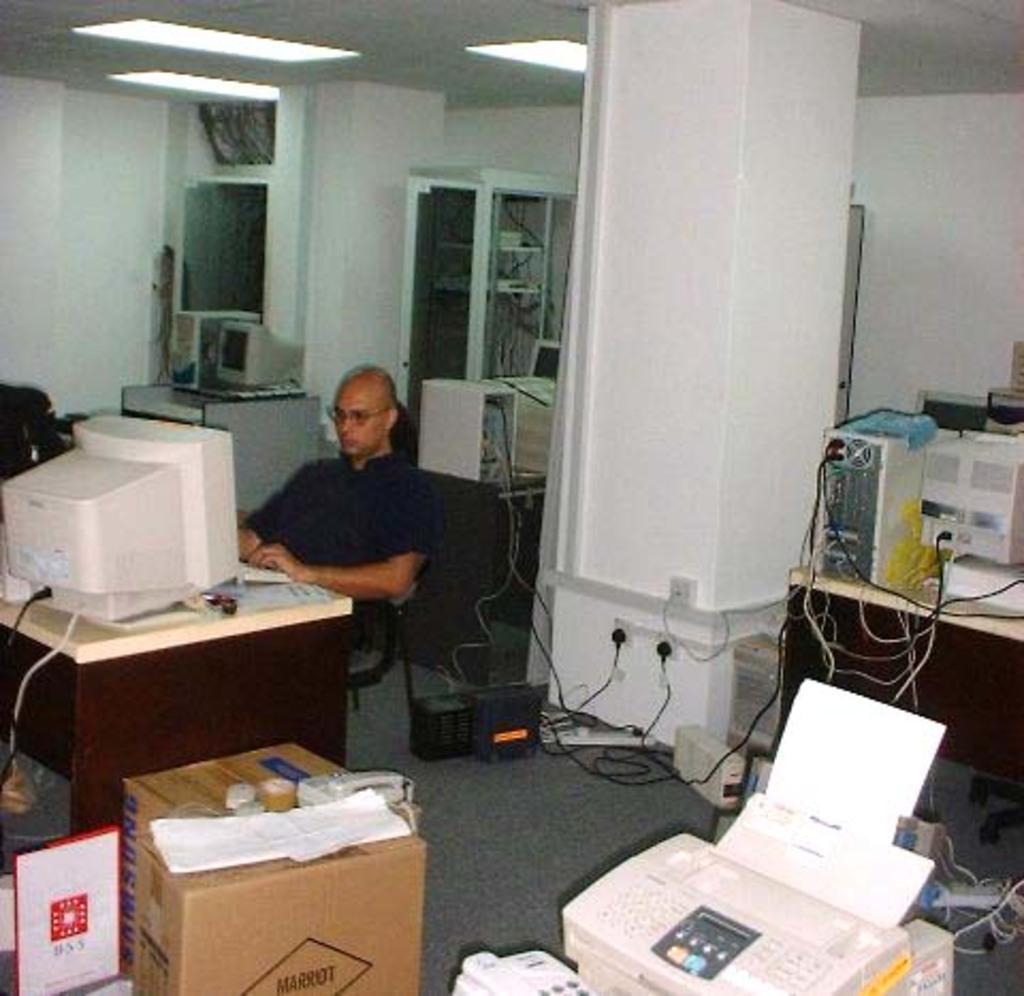Can you describe this image briefly? There is a man sitting on the chair. Here we can see tables, monitors, CPU, devices, cables, and boxes. There is a pillar. In the background we can see lights and wall. 